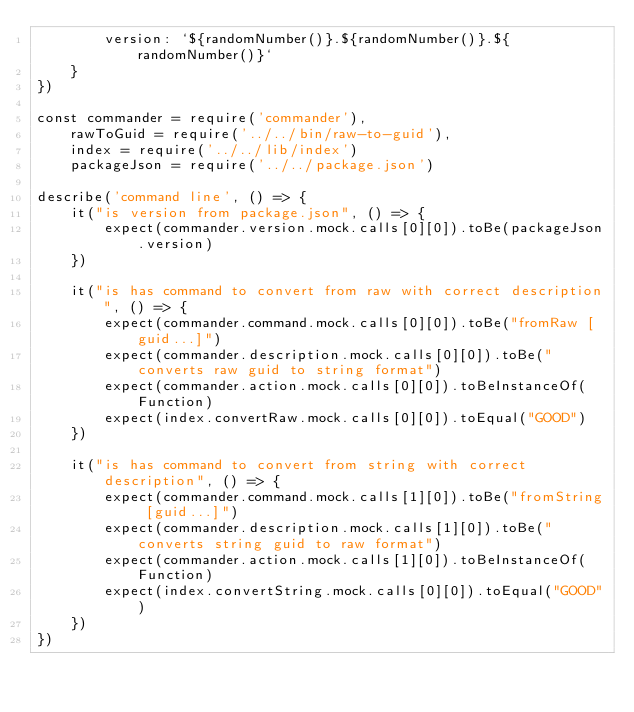<code> <loc_0><loc_0><loc_500><loc_500><_JavaScript_>        version: `${randomNumber()}.${randomNumber()}.${randomNumber()}`
    }
})

const commander = require('commander'),
    rawToGuid = require('../../bin/raw-to-guid'),
    index = require('../../lib/index')
    packageJson = require('../../package.json')

describe('command line', () => {
    it("is version from package.json", () => {
        expect(commander.version.mock.calls[0][0]).toBe(packageJson.version)
    })

    it("is has command to convert from raw with correct description", () => {
        expect(commander.command.mock.calls[0][0]).toBe("fromRaw [guid...]")
        expect(commander.description.mock.calls[0][0]).toBe("converts raw guid to string format")
        expect(commander.action.mock.calls[0][0]).toBeInstanceOf(Function)
        expect(index.convertRaw.mock.calls[0][0]).toEqual("GOOD")
    })

    it("is has command to convert from string with correct description", () => {
        expect(commander.command.mock.calls[1][0]).toBe("fromString [guid...]")
        expect(commander.description.mock.calls[1][0]).toBe("converts string guid to raw format")
        expect(commander.action.mock.calls[1][0]).toBeInstanceOf(Function)
        expect(index.convertString.mock.calls[0][0]).toEqual("GOOD")
    })
})</code> 